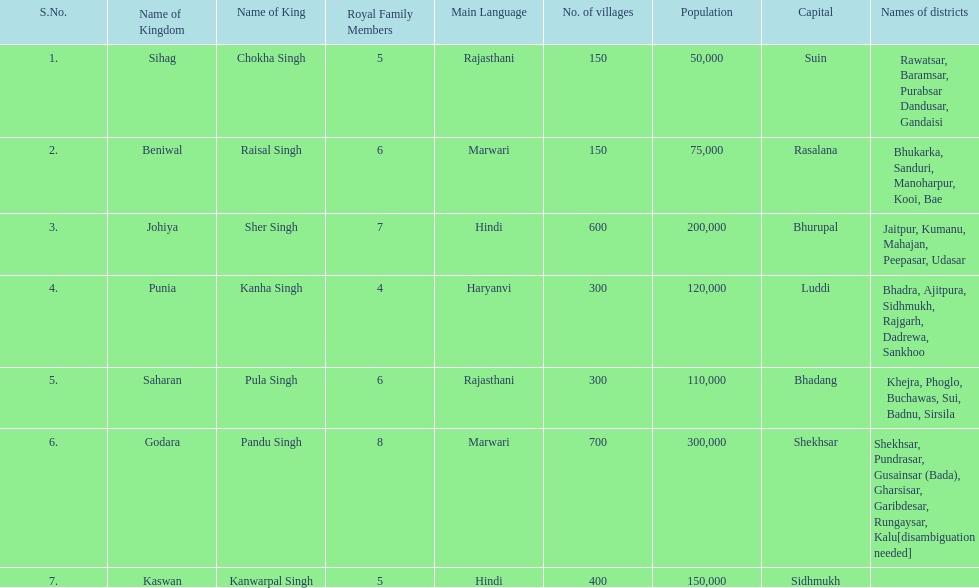Which kingdom contained the second most villages, next only to godara? Johiya. 